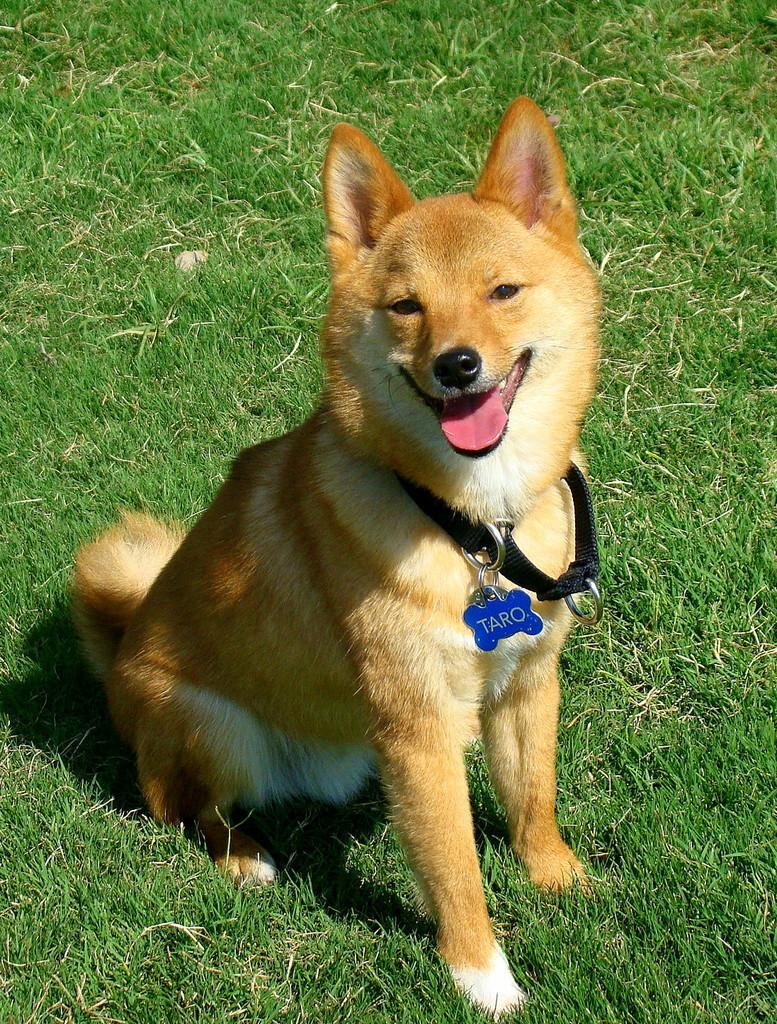What animal can be seen in the image? There is a dog in the image. Where is the dog located? The dog is sitting on the grass. What is the dog doing in the image? The dog is watching something. What accessory is the dog wearing in the image? The dog has a belt with a locket on its neck. How does the dog push the gate open in the image? There is no gate present in the image, so the dog cannot push it open. 